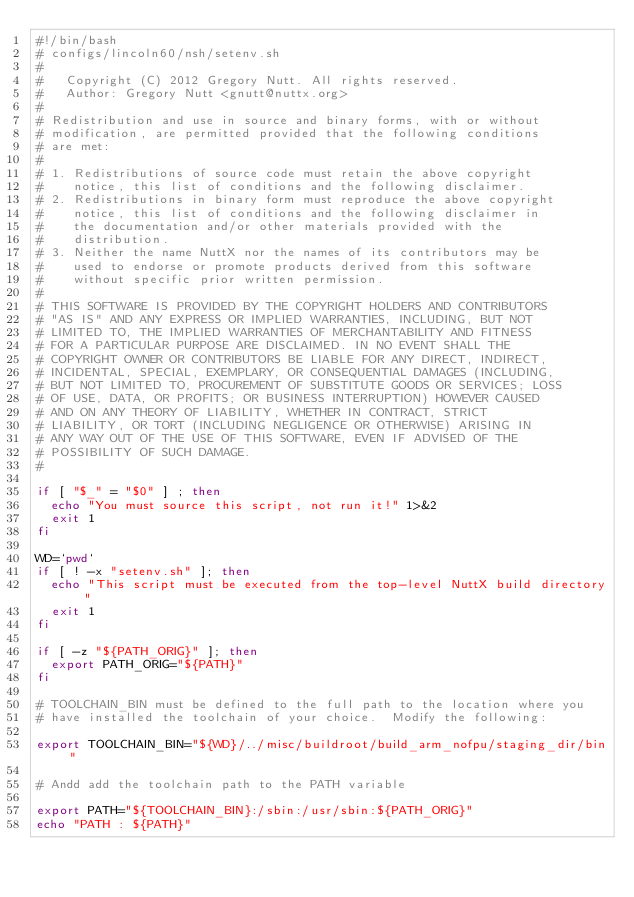<code> <loc_0><loc_0><loc_500><loc_500><_Bash_>#!/bin/bash
# configs/lincoln60/nsh/setenv.sh
#
#   Copyright (C) 2012 Gregory Nutt. All rights reserved.
#   Author: Gregory Nutt <gnutt@nuttx.org>
#
# Redistribution and use in source and binary forms, with or without
# modification, are permitted provided that the following conditions
# are met:
#
# 1. Redistributions of source code must retain the above copyright
#    notice, this list of conditions and the following disclaimer.
# 2. Redistributions in binary form must reproduce the above copyright
#    notice, this list of conditions and the following disclaimer in
#    the documentation and/or other materials provided with the
#    distribution.
# 3. Neither the name NuttX nor the names of its contributors may be
#    used to endorse or promote products derived from this software
#    without specific prior written permission.
#
# THIS SOFTWARE IS PROVIDED BY THE COPYRIGHT HOLDERS AND CONTRIBUTORS
# "AS IS" AND ANY EXPRESS OR IMPLIED WARRANTIES, INCLUDING, BUT NOT
# LIMITED TO, THE IMPLIED WARRANTIES OF MERCHANTABILITY AND FITNESS
# FOR A PARTICULAR PURPOSE ARE DISCLAIMED. IN NO EVENT SHALL THE
# COPYRIGHT OWNER OR CONTRIBUTORS BE LIABLE FOR ANY DIRECT, INDIRECT,
# INCIDENTAL, SPECIAL, EXEMPLARY, OR CONSEQUENTIAL DAMAGES (INCLUDING,
# BUT NOT LIMITED TO, PROCUREMENT OF SUBSTITUTE GOODS OR SERVICES; LOSS
# OF USE, DATA, OR PROFITS; OR BUSINESS INTERRUPTION) HOWEVER CAUSED
# AND ON ANY THEORY OF LIABILITY, WHETHER IN CONTRACT, STRICT
# LIABILITY, OR TORT (INCLUDING NEGLIGENCE OR OTHERWISE) ARISING IN
# ANY WAY OUT OF THE USE OF THIS SOFTWARE, EVEN IF ADVISED OF THE
# POSSIBILITY OF SUCH DAMAGE.
#

if [ "$_" = "$0" ] ; then
  echo "You must source this script, not run it!" 1>&2
  exit 1
fi

WD=`pwd`
if [ ! -x "setenv.sh" ]; then
  echo "This script must be executed from the top-level NuttX build directory"
  exit 1
fi

if [ -z "${PATH_ORIG}" ]; then
  export PATH_ORIG="${PATH}"
fi

# TOOLCHAIN_BIN must be defined to the full path to the location where you
# have installed the toolchain of your choice.  Modify the following:

export TOOLCHAIN_BIN="${WD}/../misc/buildroot/build_arm_nofpu/staging_dir/bin"

# Andd add the toolchain path to the PATH variable

export PATH="${TOOLCHAIN_BIN}:/sbin:/usr/sbin:${PATH_ORIG}"
echo "PATH : ${PATH}"
</code> 